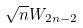<formula> <loc_0><loc_0><loc_500><loc_500>\sqrt { n } W _ { 2 n - 2 }</formula> 